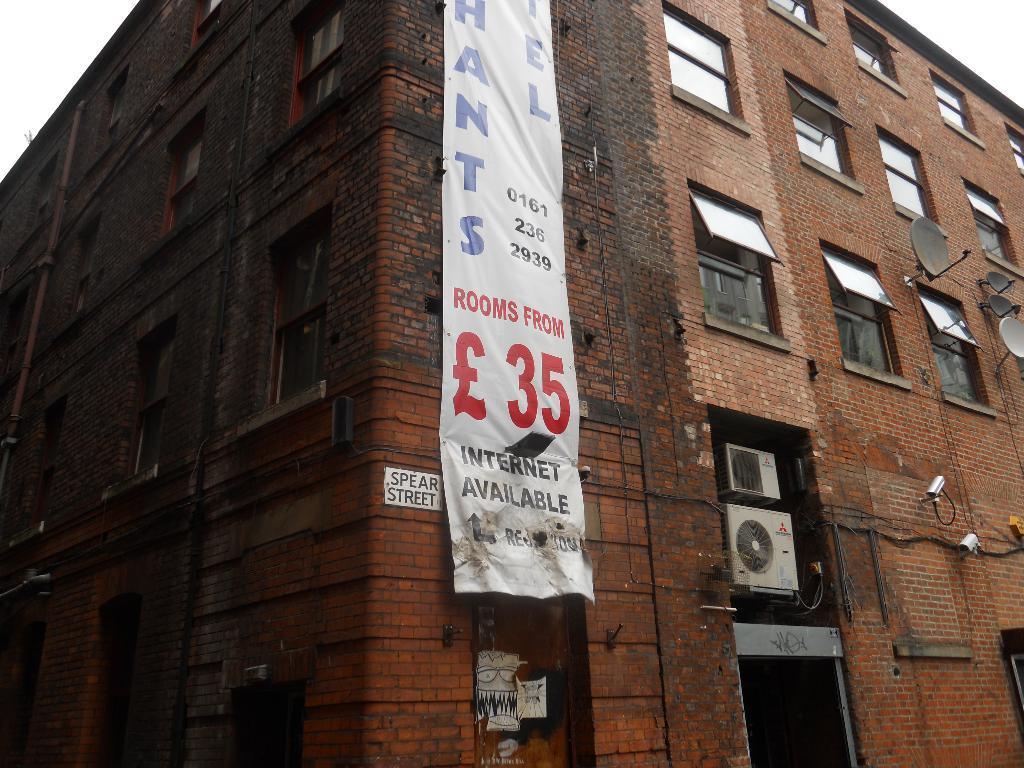Could you give a brief overview of what you see in this image? In this image there is a building with a banner on it, on the banner there is some text, on the building there is nameplate, air conditioners, cameras, dish antennas and glass windows. 